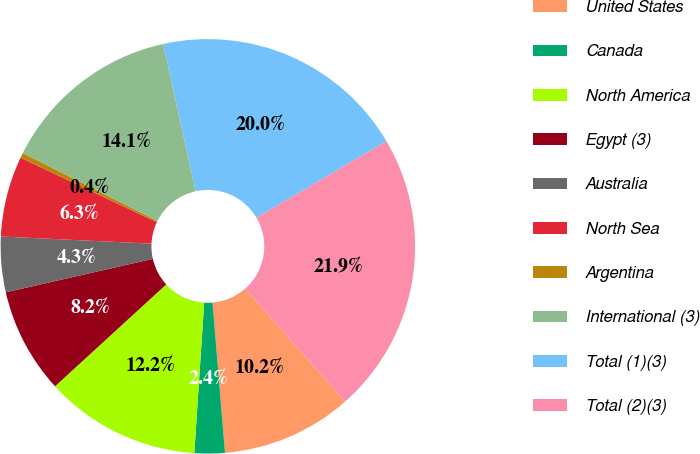<chart> <loc_0><loc_0><loc_500><loc_500><pie_chart><fcel>United States<fcel>Canada<fcel>North America<fcel>Egypt (3)<fcel>Australia<fcel>North Sea<fcel>Argentina<fcel>International (3)<fcel>Total (1)(3)<fcel>Total (2)(3)<nl><fcel>10.2%<fcel>2.36%<fcel>12.16%<fcel>8.24%<fcel>4.32%<fcel>6.28%<fcel>0.4%<fcel>14.11%<fcel>19.99%<fcel>21.95%<nl></chart> 